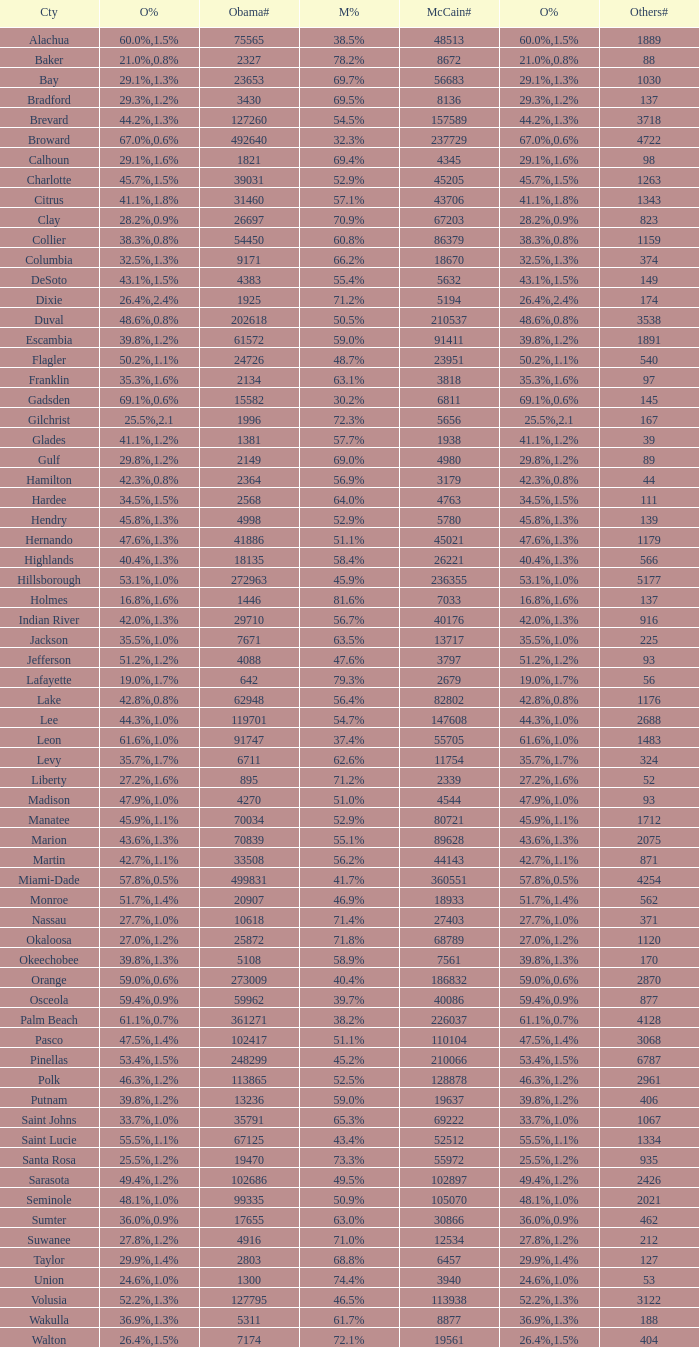How many numbers were recorded under Obama when he had 29.9% voters? 1.0. Parse the full table. {'header': ['Cty', 'O%', 'Obama#', 'M%', 'McCain#', 'O%', 'Others#'], 'rows': [['Alachua', '60.0%', '75565', '38.5%', '48513', '1.5%', '1889'], ['Baker', '21.0%', '2327', '78.2%', '8672', '0.8%', '88'], ['Bay', '29.1%', '23653', '69.7%', '56683', '1.3%', '1030'], ['Bradford', '29.3%', '3430', '69.5%', '8136', '1.2%', '137'], ['Brevard', '44.2%', '127260', '54.5%', '157589', '1.3%', '3718'], ['Broward', '67.0%', '492640', '32.3%', '237729', '0.6%', '4722'], ['Calhoun', '29.1%', '1821', '69.4%', '4345', '1.6%', '98'], ['Charlotte', '45.7%', '39031', '52.9%', '45205', '1.5%', '1263'], ['Citrus', '41.1%', '31460', '57.1%', '43706', '1.8%', '1343'], ['Clay', '28.2%', '26697', '70.9%', '67203', '0.9%', '823'], ['Collier', '38.3%', '54450', '60.8%', '86379', '0.8%', '1159'], ['Columbia', '32.5%', '9171', '66.2%', '18670', '1.3%', '374'], ['DeSoto', '43.1%', '4383', '55.4%', '5632', '1.5%', '149'], ['Dixie', '26.4%', '1925', '71.2%', '5194', '2.4%', '174'], ['Duval', '48.6%', '202618', '50.5%', '210537', '0.8%', '3538'], ['Escambia', '39.8%', '61572', '59.0%', '91411', '1.2%', '1891'], ['Flagler', '50.2%', '24726', '48.7%', '23951', '1.1%', '540'], ['Franklin', '35.3%', '2134', '63.1%', '3818', '1.6%', '97'], ['Gadsden', '69.1%', '15582', '30.2%', '6811', '0.6%', '145'], ['Gilchrist', '25.5%', '1996', '72.3%', '5656', '2.1', '167'], ['Glades', '41.1%', '1381', '57.7%', '1938', '1.2%', '39'], ['Gulf', '29.8%', '2149', '69.0%', '4980', '1.2%', '89'], ['Hamilton', '42.3%', '2364', '56.9%', '3179', '0.8%', '44'], ['Hardee', '34.5%', '2568', '64.0%', '4763', '1.5%', '111'], ['Hendry', '45.8%', '4998', '52.9%', '5780', '1.3%', '139'], ['Hernando', '47.6%', '41886', '51.1%', '45021', '1.3%', '1179'], ['Highlands', '40.4%', '18135', '58.4%', '26221', '1.3%', '566'], ['Hillsborough', '53.1%', '272963', '45.9%', '236355', '1.0%', '5177'], ['Holmes', '16.8%', '1446', '81.6%', '7033', '1.6%', '137'], ['Indian River', '42.0%', '29710', '56.7%', '40176', '1.3%', '916'], ['Jackson', '35.5%', '7671', '63.5%', '13717', '1.0%', '225'], ['Jefferson', '51.2%', '4088', '47.6%', '3797', '1.2%', '93'], ['Lafayette', '19.0%', '642', '79.3%', '2679', '1.7%', '56'], ['Lake', '42.8%', '62948', '56.4%', '82802', '0.8%', '1176'], ['Lee', '44.3%', '119701', '54.7%', '147608', '1.0%', '2688'], ['Leon', '61.6%', '91747', '37.4%', '55705', '1.0%', '1483'], ['Levy', '35.7%', '6711', '62.6%', '11754', '1.7%', '324'], ['Liberty', '27.2%', '895', '71.2%', '2339', '1.6%', '52'], ['Madison', '47.9%', '4270', '51.0%', '4544', '1.0%', '93'], ['Manatee', '45.9%', '70034', '52.9%', '80721', '1.1%', '1712'], ['Marion', '43.6%', '70839', '55.1%', '89628', '1.3%', '2075'], ['Martin', '42.7%', '33508', '56.2%', '44143', '1.1%', '871'], ['Miami-Dade', '57.8%', '499831', '41.7%', '360551', '0.5%', '4254'], ['Monroe', '51.7%', '20907', '46.9%', '18933', '1.4%', '562'], ['Nassau', '27.7%', '10618', '71.4%', '27403', '1.0%', '371'], ['Okaloosa', '27.0%', '25872', '71.8%', '68789', '1.2%', '1120'], ['Okeechobee', '39.8%', '5108', '58.9%', '7561', '1.3%', '170'], ['Orange', '59.0%', '273009', '40.4%', '186832', '0.6%', '2870'], ['Osceola', '59.4%', '59962', '39.7%', '40086', '0.9%', '877'], ['Palm Beach', '61.1%', '361271', '38.2%', '226037', '0.7%', '4128'], ['Pasco', '47.5%', '102417', '51.1%', '110104', '1.4%', '3068'], ['Pinellas', '53.4%', '248299', '45.2%', '210066', '1.5%', '6787'], ['Polk', '46.3%', '113865', '52.5%', '128878', '1.2%', '2961'], ['Putnam', '39.8%', '13236', '59.0%', '19637', '1.2%', '406'], ['Saint Johns', '33.7%', '35791', '65.3%', '69222', '1.0%', '1067'], ['Saint Lucie', '55.5%', '67125', '43.4%', '52512', '1.1%', '1334'], ['Santa Rosa', '25.5%', '19470', '73.3%', '55972', '1.2%', '935'], ['Sarasota', '49.4%', '102686', '49.5%', '102897', '1.2%', '2426'], ['Seminole', '48.1%', '99335', '50.9%', '105070', '1.0%', '2021'], ['Sumter', '36.0%', '17655', '63.0%', '30866', '0.9%', '462'], ['Suwanee', '27.8%', '4916', '71.0%', '12534', '1.2%', '212'], ['Taylor', '29.9%', '2803', '68.8%', '6457', '1.4%', '127'], ['Union', '24.6%', '1300', '74.4%', '3940', '1.0%', '53'], ['Volusia', '52.2%', '127795', '46.5%', '113938', '1.3%', '3122'], ['Wakulla', '36.9%', '5311', '61.7%', '8877', '1.3%', '188'], ['Walton', '26.4%', '7174', '72.1%', '19561', '1.5%', '404']]} 